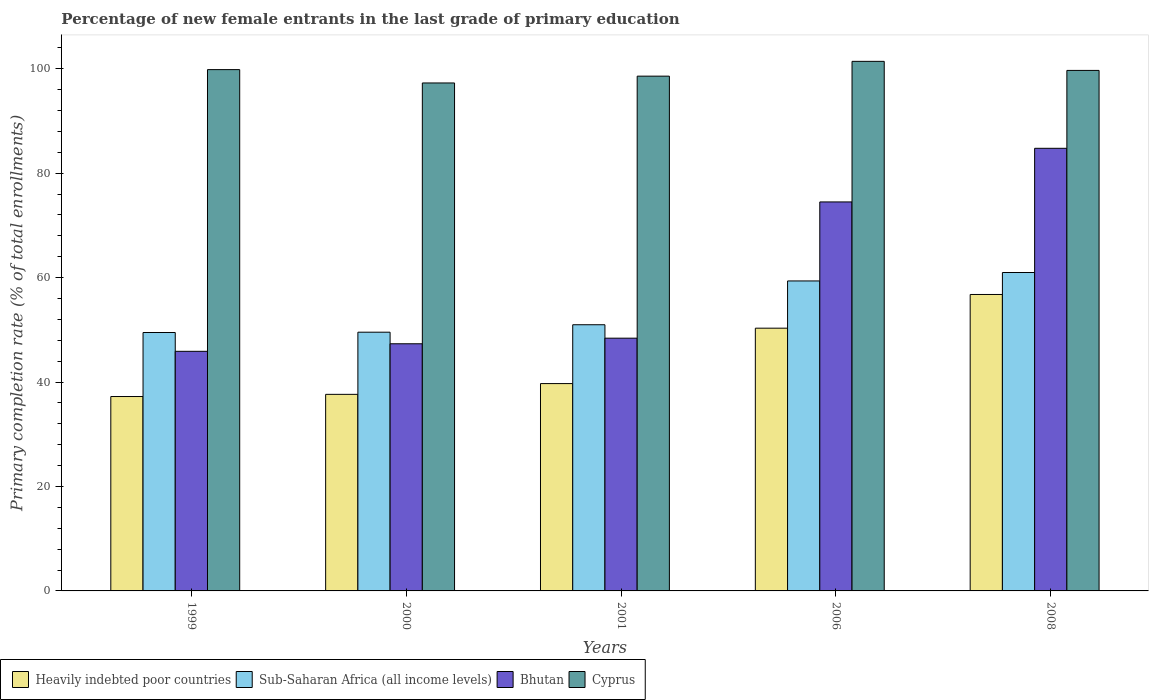Are the number of bars on each tick of the X-axis equal?
Your answer should be very brief. Yes. How many bars are there on the 1st tick from the left?
Keep it short and to the point. 4. How many bars are there on the 4th tick from the right?
Provide a succinct answer. 4. What is the label of the 1st group of bars from the left?
Offer a very short reply. 1999. What is the percentage of new female entrants in Bhutan in 2006?
Make the answer very short. 74.49. Across all years, what is the maximum percentage of new female entrants in Cyprus?
Keep it short and to the point. 101.41. Across all years, what is the minimum percentage of new female entrants in Cyprus?
Ensure brevity in your answer.  97.27. What is the total percentage of new female entrants in Cyprus in the graph?
Your response must be concise. 496.77. What is the difference between the percentage of new female entrants in Cyprus in 1999 and that in 2001?
Your response must be concise. 1.25. What is the difference between the percentage of new female entrants in Sub-Saharan Africa (all income levels) in 2008 and the percentage of new female entrants in Bhutan in 2000?
Keep it short and to the point. 13.65. What is the average percentage of new female entrants in Bhutan per year?
Your response must be concise. 60.17. In the year 2001, what is the difference between the percentage of new female entrants in Bhutan and percentage of new female entrants in Sub-Saharan Africa (all income levels)?
Give a very brief answer. -2.57. In how many years, is the percentage of new female entrants in Bhutan greater than 12 %?
Give a very brief answer. 5. What is the ratio of the percentage of new female entrants in Heavily indebted poor countries in 1999 to that in 2000?
Give a very brief answer. 0.99. What is the difference between the highest and the second highest percentage of new female entrants in Sub-Saharan Africa (all income levels)?
Keep it short and to the point. 1.62. What is the difference between the highest and the lowest percentage of new female entrants in Heavily indebted poor countries?
Offer a very short reply. 19.54. In how many years, is the percentage of new female entrants in Sub-Saharan Africa (all income levels) greater than the average percentage of new female entrants in Sub-Saharan Africa (all income levels) taken over all years?
Provide a short and direct response. 2. What does the 4th bar from the left in 2006 represents?
Your answer should be compact. Cyprus. What does the 4th bar from the right in 1999 represents?
Give a very brief answer. Heavily indebted poor countries. Is it the case that in every year, the sum of the percentage of new female entrants in Sub-Saharan Africa (all income levels) and percentage of new female entrants in Bhutan is greater than the percentage of new female entrants in Heavily indebted poor countries?
Provide a succinct answer. Yes. How many bars are there?
Your answer should be very brief. 20. How many years are there in the graph?
Your answer should be compact. 5. Are the values on the major ticks of Y-axis written in scientific E-notation?
Offer a very short reply. No. Does the graph contain any zero values?
Make the answer very short. No. Does the graph contain grids?
Your answer should be compact. No. Where does the legend appear in the graph?
Ensure brevity in your answer.  Bottom left. How many legend labels are there?
Make the answer very short. 4. How are the legend labels stacked?
Give a very brief answer. Horizontal. What is the title of the graph?
Your answer should be very brief. Percentage of new female entrants in the last grade of primary education. What is the label or title of the X-axis?
Make the answer very short. Years. What is the label or title of the Y-axis?
Your answer should be compact. Primary completion rate (% of total enrollments). What is the Primary completion rate (% of total enrollments) in Heavily indebted poor countries in 1999?
Offer a very short reply. 37.23. What is the Primary completion rate (% of total enrollments) in Sub-Saharan Africa (all income levels) in 1999?
Ensure brevity in your answer.  49.48. What is the Primary completion rate (% of total enrollments) of Bhutan in 1999?
Your answer should be very brief. 45.88. What is the Primary completion rate (% of total enrollments) of Cyprus in 1999?
Keep it short and to the point. 99.83. What is the Primary completion rate (% of total enrollments) of Heavily indebted poor countries in 2000?
Your response must be concise. 37.64. What is the Primary completion rate (% of total enrollments) of Sub-Saharan Africa (all income levels) in 2000?
Your answer should be compact. 49.55. What is the Primary completion rate (% of total enrollments) of Bhutan in 2000?
Your answer should be very brief. 47.33. What is the Primary completion rate (% of total enrollments) in Cyprus in 2000?
Offer a terse response. 97.27. What is the Primary completion rate (% of total enrollments) of Heavily indebted poor countries in 2001?
Provide a succinct answer. 39.71. What is the Primary completion rate (% of total enrollments) of Sub-Saharan Africa (all income levels) in 2001?
Your response must be concise. 50.97. What is the Primary completion rate (% of total enrollments) of Bhutan in 2001?
Provide a succinct answer. 48.4. What is the Primary completion rate (% of total enrollments) in Cyprus in 2001?
Make the answer very short. 98.58. What is the Primary completion rate (% of total enrollments) in Heavily indebted poor countries in 2006?
Your response must be concise. 50.31. What is the Primary completion rate (% of total enrollments) in Sub-Saharan Africa (all income levels) in 2006?
Offer a very short reply. 59.36. What is the Primary completion rate (% of total enrollments) in Bhutan in 2006?
Give a very brief answer. 74.49. What is the Primary completion rate (% of total enrollments) in Cyprus in 2006?
Make the answer very short. 101.41. What is the Primary completion rate (% of total enrollments) in Heavily indebted poor countries in 2008?
Your answer should be very brief. 56.77. What is the Primary completion rate (% of total enrollments) in Sub-Saharan Africa (all income levels) in 2008?
Give a very brief answer. 60.98. What is the Primary completion rate (% of total enrollments) of Bhutan in 2008?
Provide a succinct answer. 84.76. What is the Primary completion rate (% of total enrollments) in Cyprus in 2008?
Provide a succinct answer. 99.68. Across all years, what is the maximum Primary completion rate (% of total enrollments) of Heavily indebted poor countries?
Your answer should be compact. 56.77. Across all years, what is the maximum Primary completion rate (% of total enrollments) of Sub-Saharan Africa (all income levels)?
Offer a terse response. 60.98. Across all years, what is the maximum Primary completion rate (% of total enrollments) of Bhutan?
Make the answer very short. 84.76. Across all years, what is the maximum Primary completion rate (% of total enrollments) in Cyprus?
Keep it short and to the point. 101.41. Across all years, what is the minimum Primary completion rate (% of total enrollments) in Heavily indebted poor countries?
Offer a very short reply. 37.23. Across all years, what is the minimum Primary completion rate (% of total enrollments) in Sub-Saharan Africa (all income levels)?
Your answer should be compact. 49.48. Across all years, what is the minimum Primary completion rate (% of total enrollments) in Bhutan?
Your answer should be very brief. 45.88. Across all years, what is the minimum Primary completion rate (% of total enrollments) in Cyprus?
Offer a very short reply. 97.27. What is the total Primary completion rate (% of total enrollments) of Heavily indebted poor countries in the graph?
Offer a terse response. 221.66. What is the total Primary completion rate (% of total enrollments) in Sub-Saharan Africa (all income levels) in the graph?
Make the answer very short. 270.34. What is the total Primary completion rate (% of total enrollments) of Bhutan in the graph?
Offer a terse response. 300.86. What is the total Primary completion rate (% of total enrollments) of Cyprus in the graph?
Provide a succinct answer. 496.77. What is the difference between the Primary completion rate (% of total enrollments) of Heavily indebted poor countries in 1999 and that in 2000?
Your response must be concise. -0.41. What is the difference between the Primary completion rate (% of total enrollments) in Sub-Saharan Africa (all income levels) in 1999 and that in 2000?
Ensure brevity in your answer.  -0.06. What is the difference between the Primary completion rate (% of total enrollments) in Bhutan in 1999 and that in 2000?
Make the answer very short. -1.45. What is the difference between the Primary completion rate (% of total enrollments) of Cyprus in 1999 and that in 2000?
Ensure brevity in your answer.  2.55. What is the difference between the Primary completion rate (% of total enrollments) of Heavily indebted poor countries in 1999 and that in 2001?
Your answer should be very brief. -2.48. What is the difference between the Primary completion rate (% of total enrollments) in Sub-Saharan Africa (all income levels) in 1999 and that in 2001?
Give a very brief answer. -1.49. What is the difference between the Primary completion rate (% of total enrollments) of Bhutan in 1999 and that in 2001?
Give a very brief answer. -2.52. What is the difference between the Primary completion rate (% of total enrollments) in Cyprus in 1999 and that in 2001?
Your answer should be very brief. 1.25. What is the difference between the Primary completion rate (% of total enrollments) of Heavily indebted poor countries in 1999 and that in 2006?
Provide a succinct answer. -13.09. What is the difference between the Primary completion rate (% of total enrollments) in Sub-Saharan Africa (all income levels) in 1999 and that in 2006?
Offer a very short reply. -9.88. What is the difference between the Primary completion rate (% of total enrollments) in Bhutan in 1999 and that in 2006?
Your answer should be very brief. -28.61. What is the difference between the Primary completion rate (% of total enrollments) in Cyprus in 1999 and that in 2006?
Give a very brief answer. -1.58. What is the difference between the Primary completion rate (% of total enrollments) of Heavily indebted poor countries in 1999 and that in 2008?
Your answer should be compact. -19.54. What is the difference between the Primary completion rate (% of total enrollments) of Sub-Saharan Africa (all income levels) in 1999 and that in 2008?
Give a very brief answer. -11.49. What is the difference between the Primary completion rate (% of total enrollments) in Bhutan in 1999 and that in 2008?
Offer a very short reply. -38.88. What is the difference between the Primary completion rate (% of total enrollments) in Cyprus in 1999 and that in 2008?
Your answer should be compact. 0.15. What is the difference between the Primary completion rate (% of total enrollments) in Heavily indebted poor countries in 2000 and that in 2001?
Make the answer very short. -2.06. What is the difference between the Primary completion rate (% of total enrollments) of Sub-Saharan Africa (all income levels) in 2000 and that in 2001?
Your answer should be compact. -1.43. What is the difference between the Primary completion rate (% of total enrollments) in Bhutan in 2000 and that in 2001?
Ensure brevity in your answer.  -1.07. What is the difference between the Primary completion rate (% of total enrollments) of Cyprus in 2000 and that in 2001?
Offer a terse response. -1.31. What is the difference between the Primary completion rate (% of total enrollments) in Heavily indebted poor countries in 2000 and that in 2006?
Your answer should be compact. -12.67. What is the difference between the Primary completion rate (% of total enrollments) in Sub-Saharan Africa (all income levels) in 2000 and that in 2006?
Your response must be concise. -9.81. What is the difference between the Primary completion rate (% of total enrollments) of Bhutan in 2000 and that in 2006?
Your answer should be compact. -27.16. What is the difference between the Primary completion rate (% of total enrollments) of Cyprus in 2000 and that in 2006?
Provide a succinct answer. -4.14. What is the difference between the Primary completion rate (% of total enrollments) in Heavily indebted poor countries in 2000 and that in 2008?
Your answer should be very brief. -19.13. What is the difference between the Primary completion rate (% of total enrollments) in Sub-Saharan Africa (all income levels) in 2000 and that in 2008?
Keep it short and to the point. -11.43. What is the difference between the Primary completion rate (% of total enrollments) of Bhutan in 2000 and that in 2008?
Your answer should be compact. -37.43. What is the difference between the Primary completion rate (% of total enrollments) in Cyprus in 2000 and that in 2008?
Give a very brief answer. -2.4. What is the difference between the Primary completion rate (% of total enrollments) of Heavily indebted poor countries in 2001 and that in 2006?
Offer a very short reply. -10.61. What is the difference between the Primary completion rate (% of total enrollments) of Sub-Saharan Africa (all income levels) in 2001 and that in 2006?
Offer a terse response. -8.39. What is the difference between the Primary completion rate (% of total enrollments) in Bhutan in 2001 and that in 2006?
Keep it short and to the point. -26.09. What is the difference between the Primary completion rate (% of total enrollments) of Cyprus in 2001 and that in 2006?
Offer a very short reply. -2.83. What is the difference between the Primary completion rate (% of total enrollments) of Heavily indebted poor countries in 2001 and that in 2008?
Give a very brief answer. -17.06. What is the difference between the Primary completion rate (% of total enrollments) of Sub-Saharan Africa (all income levels) in 2001 and that in 2008?
Your answer should be very brief. -10.01. What is the difference between the Primary completion rate (% of total enrollments) in Bhutan in 2001 and that in 2008?
Your answer should be very brief. -36.36. What is the difference between the Primary completion rate (% of total enrollments) in Cyprus in 2001 and that in 2008?
Offer a terse response. -1.1. What is the difference between the Primary completion rate (% of total enrollments) of Heavily indebted poor countries in 2006 and that in 2008?
Give a very brief answer. -6.46. What is the difference between the Primary completion rate (% of total enrollments) of Sub-Saharan Africa (all income levels) in 2006 and that in 2008?
Keep it short and to the point. -1.62. What is the difference between the Primary completion rate (% of total enrollments) of Bhutan in 2006 and that in 2008?
Your answer should be compact. -10.27. What is the difference between the Primary completion rate (% of total enrollments) in Cyprus in 2006 and that in 2008?
Keep it short and to the point. 1.74. What is the difference between the Primary completion rate (% of total enrollments) of Heavily indebted poor countries in 1999 and the Primary completion rate (% of total enrollments) of Sub-Saharan Africa (all income levels) in 2000?
Make the answer very short. -12.32. What is the difference between the Primary completion rate (% of total enrollments) of Heavily indebted poor countries in 1999 and the Primary completion rate (% of total enrollments) of Bhutan in 2000?
Keep it short and to the point. -10.1. What is the difference between the Primary completion rate (% of total enrollments) of Heavily indebted poor countries in 1999 and the Primary completion rate (% of total enrollments) of Cyprus in 2000?
Keep it short and to the point. -60.05. What is the difference between the Primary completion rate (% of total enrollments) in Sub-Saharan Africa (all income levels) in 1999 and the Primary completion rate (% of total enrollments) in Bhutan in 2000?
Give a very brief answer. 2.15. What is the difference between the Primary completion rate (% of total enrollments) in Sub-Saharan Africa (all income levels) in 1999 and the Primary completion rate (% of total enrollments) in Cyprus in 2000?
Offer a very short reply. -47.79. What is the difference between the Primary completion rate (% of total enrollments) of Bhutan in 1999 and the Primary completion rate (% of total enrollments) of Cyprus in 2000?
Make the answer very short. -51.39. What is the difference between the Primary completion rate (% of total enrollments) in Heavily indebted poor countries in 1999 and the Primary completion rate (% of total enrollments) in Sub-Saharan Africa (all income levels) in 2001?
Offer a terse response. -13.74. What is the difference between the Primary completion rate (% of total enrollments) of Heavily indebted poor countries in 1999 and the Primary completion rate (% of total enrollments) of Bhutan in 2001?
Provide a succinct answer. -11.17. What is the difference between the Primary completion rate (% of total enrollments) of Heavily indebted poor countries in 1999 and the Primary completion rate (% of total enrollments) of Cyprus in 2001?
Your answer should be compact. -61.35. What is the difference between the Primary completion rate (% of total enrollments) of Sub-Saharan Africa (all income levels) in 1999 and the Primary completion rate (% of total enrollments) of Bhutan in 2001?
Offer a very short reply. 1.08. What is the difference between the Primary completion rate (% of total enrollments) of Sub-Saharan Africa (all income levels) in 1999 and the Primary completion rate (% of total enrollments) of Cyprus in 2001?
Provide a succinct answer. -49.09. What is the difference between the Primary completion rate (% of total enrollments) in Bhutan in 1999 and the Primary completion rate (% of total enrollments) in Cyprus in 2001?
Ensure brevity in your answer.  -52.7. What is the difference between the Primary completion rate (% of total enrollments) in Heavily indebted poor countries in 1999 and the Primary completion rate (% of total enrollments) in Sub-Saharan Africa (all income levels) in 2006?
Offer a terse response. -22.13. What is the difference between the Primary completion rate (% of total enrollments) of Heavily indebted poor countries in 1999 and the Primary completion rate (% of total enrollments) of Bhutan in 2006?
Provide a short and direct response. -37.26. What is the difference between the Primary completion rate (% of total enrollments) of Heavily indebted poor countries in 1999 and the Primary completion rate (% of total enrollments) of Cyprus in 2006?
Make the answer very short. -64.18. What is the difference between the Primary completion rate (% of total enrollments) of Sub-Saharan Africa (all income levels) in 1999 and the Primary completion rate (% of total enrollments) of Bhutan in 2006?
Keep it short and to the point. -25.01. What is the difference between the Primary completion rate (% of total enrollments) in Sub-Saharan Africa (all income levels) in 1999 and the Primary completion rate (% of total enrollments) in Cyprus in 2006?
Offer a terse response. -51.93. What is the difference between the Primary completion rate (% of total enrollments) in Bhutan in 1999 and the Primary completion rate (% of total enrollments) in Cyprus in 2006?
Give a very brief answer. -55.53. What is the difference between the Primary completion rate (% of total enrollments) of Heavily indebted poor countries in 1999 and the Primary completion rate (% of total enrollments) of Sub-Saharan Africa (all income levels) in 2008?
Your response must be concise. -23.75. What is the difference between the Primary completion rate (% of total enrollments) in Heavily indebted poor countries in 1999 and the Primary completion rate (% of total enrollments) in Bhutan in 2008?
Keep it short and to the point. -47.53. What is the difference between the Primary completion rate (% of total enrollments) in Heavily indebted poor countries in 1999 and the Primary completion rate (% of total enrollments) in Cyprus in 2008?
Offer a very short reply. -62.45. What is the difference between the Primary completion rate (% of total enrollments) of Sub-Saharan Africa (all income levels) in 1999 and the Primary completion rate (% of total enrollments) of Bhutan in 2008?
Provide a succinct answer. -35.28. What is the difference between the Primary completion rate (% of total enrollments) of Sub-Saharan Africa (all income levels) in 1999 and the Primary completion rate (% of total enrollments) of Cyprus in 2008?
Keep it short and to the point. -50.19. What is the difference between the Primary completion rate (% of total enrollments) in Bhutan in 1999 and the Primary completion rate (% of total enrollments) in Cyprus in 2008?
Your answer should be compact. -53.79. What is the difference between the Primary completion rate (% of total enrollments) in Heavily indebted poor countries in 2000 and the Primary completion rate (% of total enrollments) in Sub-Saharan Africa (all income levels) in 2001?
Your answer should be very brief. -13.33. What is the difference between the Primary completion rate (% of total enrollments) in Heavily indebted poor countries in 2000 and the Primary completion rate (% of total enrollments) in Bhutan in 2001?
Your answer should be very brief. -10.76. What is the difference between the Primary completion rate (% of total enrollments) in Heavily indebted poor countries in 2000 and the Primary completion rate (% of total enrollments) in Cyprus in 2001?
Your answer should be very brief. -60.94. What is the difference between the Primary completion rate (% of total enrollments) in Sub-Saharan Africa (all income levels) in 2000 and the Primary completion rate (% of total enrollments) in Bhutan in 2001?
Your response must be concise. 1.15. What is the difference between the Primary completion rate (% of total enrollments) in Sub-Saharan Africa (all income levels) in 2000 and the Primary completion rate (% of total enrollments) in Cyprus in 2001?
Provide a short and direct response. -49.03. What is the difference between the Primary completion rate (% of total enrollments) of Bhutan in 2000 and the Primary completion rate (% of total enrollments) of Cyprus in 2001?
Give a very brief answer. -51.25. What is the difference between the Primary completion rate (% of total enrollments) in Heavily indebted poor countries in 2000 and the Primary completion rate (% of total enrollments) in Sub-Saharan Africa (all income levels) in 2006?
Ensure brevity in your answer.  -21.72. What is the difference between the Primary completion rate (% of total enrollments) of Heavily indebted poor countries in 2000 and the Primary completion rate (% of total enrollments) of Bhutan in 2006?
Your response must be concise. -36.85. What is the difference between the Primary completion rate (% of total enrollments) of Heavily indebted poor countries in 2000 and the Primary completion rate (% of total enrollments) of Cyprus in 2006?
Offer a very short reply. -63.77. What is the difference between the Primary completion rate (% of total enrollments) of Sub-Saharan Africa (all income levels) in 2000 and the Primary completion rate (% of total enrollments) of Bhutan in 2006?
Give a very brief answer. -24.94. What is the difference between the Primary completion rate (% of total enrollments) in Sub-Saharan Africa (all income levels) in 2000 and the Primary completion rate (% of total enrollments) in Cyprus in 2006?
Offer a very short reply. -51.87. What is the difference between the Primary completion rate (% of total enrollments) in Bhutan in 2000 and the Primary completion rate (% of total enrollments) in Cyprus in 2006?
Offer a terse response. -54.08. What is the difference between the Primary completion rate (% of total enrollments) in Heavily indebted poor countries in 2000 and the Primary completion rate (% of total enrollments) in Sub-Saharan Africa (all income levels) in 2008?
Offer a very short reply. -23.33. What is the difference between the Primary completion rate (% of total enrollments) in Heavily indebted poor countries in 2000 and the Primary completion rate (% of total enrollments) in Bhutan in 2008?
Your response must be concise. -47.12. What is the difference between the Primary completion rate (% of total enrollments) of Heavily indebted poor countries in 2000 and the Primary completion rate (% of total enrollments) of Cyprus in 2008?
Make the answer very short. -62.03. What is the difference between the Primary completion rate (% of total enrollments) of Sub-Saharan Africa (all income levels) in 2000 and the Primary completion rate (% of total enrollments) of Bhutan in 2008?
Make the answer very short. -35.21. What is the difference between the Primary completion rate (% of total enrollments) in Sub-Saharan Africa (all income levels) in 2000 and the Primary completion rate (% of total enrollments) in Cyprus in 2008?
Offer a terse response. -50.13. What is the difference between the Primary completion rate (% of total enrollments) in Bhutan in 2000 and the Primary completion rate (% of total enrollments) in Cyprus in 2008?
Your answer should be compact. -52.35. What is the difference between the Primary completion rate (% of total enrollments) of Heavily indebted poor countries in 2001 and the Primary completion rate (% of total enrollments) of Sub-Saharan Africa (all income levels) in 2006?
Give a very brief answer. -19.66. What is the difference between the Primary completion rate (% of total enrollments) in Heavily indebted poor countries in 2001 and the Primary completion rate (% of total enrollments) in Bhutan in 2006?
Ensure brevity in your answer.  -34.79. What is the difference between the Primary completion rate (% of total enrollments) of Heavily indebted poor countries in 2001 and the Primary completion rate (% of total enrollments) of Cyprus in 2006?
Provide a succinct answer. -61.71. What is the difference between the Primary completion rate (% of total enrollments) of Sub-Saharan Africa (all income levels) in 2001 and the Primary completion rate (% of total enrollments) of Bhutan in 2006?
Provide a succinct answer. -23.52. What is the difference between the Primary completion rate (% of total enrollments) of Sub-Saharan Africa (all income levels) in 2001 and the Primary completion rate (% of total enrollments) of Cyprus in 2006?
Ensure brevity in your answer.  -50.44. What is the difference between the Primary completion rate (% of total enrollments) of Bhutan in 2001 and the Primary completion rate (% of total enrollments) of Cyprus in 2006?
Keep it short and to the point. -53.01. What is the difference between the Primary completion rate (% of total enrollments) of Heavily indebted poor countries in 2001 and the Primary completion rate (% of total enrollments) of Sub-Saharan Africa (all income levels) in 2008?
Ensure brevity in your answer.  -21.27. What is the difference between the Primary completion rate (% of total enrollments) in Heavily indebted poor countries in 2001 and the Primary completion rate (% of total enrollments) in Bhutan in 2008?
Provide a short and direct response. -45.05. What is the difference between the Primary completion rate (% of total enrollments) in Heavily indebted poor countries in 2001 and the Primary completion rate (% of total enrollments) in Cyprus in 2008?
Offer a terse response. -59.97. What is the difference between the Primary completion rate (% of total enrollments) in Sub-Saharan Africa (all income levels) in 2001 and the Primary completion rate (% of total enrollments) in Bhutan in 2008?
Offer a terse response. -33.79. What is the difference between the Primary completion rate (% of total enrollments) in Sub-Saharan Africa (all income levels) in 2001 and the Primary completion rate (% of total enrollments) in Cyprus in 2008?
Offer a terse response. -48.7. What is the difference between the Primary completion rate (% of total enrollments) of Bhutan in 2001 and the Primary completion rate (% of total enrollments) of Cyprus in 2008?
Keep it short and to the point. -51.28. What is the difference between the Primary completion rate (% of total enrollments) in Heavily indebted poor countries in 2006 and the Primary completion rate (% of total enrollments) in Sub-Saharan Africa (all income levels) in 2008?
Ensure brevity in your answer.  -10.66. What is the difference between the Primary completion rate (% of total enrollments) of Heavily indebted poor countries in 2006 and the Primary completion rate (% of total enrollments) of Bhutan in 2008?
Make the answer very short. -34.45. What is the difference between the Primary completion rate (% of total enrollments) of Heavily indebted poor countries in 2006 and the Primary completion rate (% of total enrollments) of Cyprus in 2008?
Offer a very short reply. -49.36. What is the difference between the Primary completion rate (% of total enrollments) of Sub-Saharan Africa (all income levels) in 2006 and the Primary completion rate (% of total enrollments) of Bhutan in 2008?
Your response must be concise. -25.4. What is the difference between the Primary completion rate (% of total enrollments) in Sub-Saharan Africa (all income levels) in 2006 and the Primary completion rate (% of total enrollments) in Cyprus in 2008?
Give a very brief answer. -40.32. What is the difference between the Primary completion rate (% of total enrollments) in Bhutan in 2006 and the Primary completion rate (% of total enrollments) in Cyprus in 2008?
Your response must be concise. -25.19. What is the average Primary completion rate (% of total enrollments) of Heavily indebted poor countries per year?
Offer a terse response. 44.33. What is the average Primary completion rate (% of total enrollments) in Sub-Saharan Africa (all income levels) per year?
Give a very brief answer. 54.07. What is the average Primary completion rate (% of total enrollments) of Bhutan per year?
Offer a very short reply. 60.17. What is the average Primary completion rate (% of total enrollments) in Cyprus per year?
Your answer should be very brief. 99.35. In the year 1999, what is the difference between the Primary completion rate (% of total enrollments) of Heavily indebted poor countries and Primary completion rate (% of total enrollments) of Sub-Saharan Africa (all income levels)?
Your response must be concise. -12.26. In the year 1999, what is the difference between the Primary completion rate (% of total enrollments) in Heavily indebted poor countries and Primary completion rate (% of total enrollments) in Bhutan?
Your response must be concise. -8.65. In the year 1999, what is the difference between the Primary completion rate (% of total enrollments) of Heavily indebted poor countries and Primary completion rate (% of total enrollments) of Cyprus?
Provide a succinct answer. -62.6. In the year 1999, what is the difference between the Primary completion rate (% of total enrollments) of Sub-Saharan Africa (all income levels) and Primary completion rate (% of total enrollments) of Bhutan?
Make the answer very short. 3.6. In the year 1999, what is the difference between the Primary completion rate (% of total enrollments) in Sub-Saharan Africa (all income levels) and Primary completion rate (% of total enrollments) in Cyprus?
Keep it short and to the point. -50.34. In the year 1999, what is the difference between the Primary completion rate (% of total enrollments) of Bhutan and Primary completion rate (% of total enrollments) of Cyprus?
Give a very brief answer. -53.95. In the year 2000, what is the difference between the Primary completion rate (% of total enrollments) of Heavily indebted poor countries and Primary completion rate (% of total enrollments) of Sub-Saharan Africa (all income levels)?
Keep it short and to the point. -11.9. In the year 2000, what is the difference between the Primary completion rate (% of total enrollments) of Heavily indebted poor countries and Primary completion rate (% of total enrollments) of Bhutan?
Give a very brief answer. -9.69. In the year 2000, what is the difference between the Primary completion rate (% of total enrollments) of Heavily indebted poor countries and Primary completion rate (% of total enrollments) of Cyprus?
Provide a succinct answer. -59.63. In the year 2000, what is the difference between the Primary completion rate (% of total enrollments) of Sub-Saharan Africa (all income levels) and Primary completion rate (% of total enrollments) of Bhutan?
Make the answer very short. 2.22. In the year 2000, what is the difference between the Primary completion rate (% of total enrollments) of Sub-Saharan Africa (all income levels) and Primary completion rate (% of total enrollments) of Cyprus?
Provide a succinct answer. -47.73. In the year 2000, what is the difference between the Primary completion rate (% of total enrollments) of Bhutan and Primary completion rate (% of total enrollments) of Cyprus?
Offer a very short reply. -49.94. In the year 2001, what is the difference between the Primary completion rate (% of total enrollments) in Heavily indebted poor countries and Primary completion rate (% of total enrollments) in Sub-Saharan Africa (all income levels)?
Offer a very short reply. -11.27. In the year 2001, what is the difference between the Primary completion rate (% of total enrollments) in Heavily indebted poor countries and Primary completion rate (% of total enrollments) in Bhutan?
Give a very brief answer. -8.69. In the year 2001, what is the difference between the Primary completion rate (% of total enrollments) in Heavily indebted poor countries and Primary completion rate (% of total enrollments) in Cyprus?
Provide a short and direct response. -58.87. In the year 2001, what is the difference between the Primary completion rate (% of total enrollments) of Sub-Saharan Africa (all income levels) and Primary completion rate (% of total enrollments) of Bhutan?
Make the answer very short. 2.57. In the year 2001, what is the difference between the Primary completion rate (% of total enrollments) of Sub-Saharan Africa (all income levels) and Primary completion rate (% of total enrollments) of Cyprus?
Keep it short and to the point. -47.61. In the year 2001, what is the difference between the Primary completion rate (% of total enrollments) of Bhutan and Primary completion rate (% of total enrollments) of Cyprus?
Your answer should be very brief. -50.18. In the year 2006, what is the difference between the Primary completion rate (% of total enrollments) of Heavily indebted poor countries and Primary completion rate (% of total enrollments) of Sub-Saharan Africa (all income levels)?
Your answer should be very brief. -9.05. In the year 2006, what is the difference between the Primary completion rate (% of total enrollments) of Heavily indebted poor countries and Primary completion rate (% of total enrollments) of Bhutan?
Give a very brief answer. -24.18. In the year 2006, what is the difference between the Primary completion rate (% of total enrollments) in Heavily indebted poor countries and Primary completion rate (% of total enrollments) in Cyprus?
Give a very brief answer. -51.1. In the year 2006, what is the difference between the Primary completion rate (% of total enrollments) in Sub-Saharan Africa (all income levels) and Primary completion rate (% of total enrollments) in Bhutan?
Provide a short and direct response. -15.13. In the year 2006, what is the difference between the Primary completion rate (% of total enrollments) in Sub-Saharan Africa (all income levels) and Primary completion rate (% of total enrollments) in Cyprus?
Keep it short and to the point. -42.05. In the year 2006, what is the difference between the Primary completion rate (% of total enrollments) in Bhutan and Primary completion rate (% of total enrollments) in Cyprus?
Provide a succinct answer. -26.92. In the year 2008, what is the difference between the Primary completion rate (% of total enrollments) of Heavily indebted poor countries and Primary completion rate (% of total enrollments) of Sub-Saharan Africa (all income levels)?
Give a very brief answer. -4.21. In the year 2008, what is the difference between the Primary completion rate (% of total enrollments) in Heavily indebted poor countries and Primary completion rate (% of total enrollments) in Bhutan?
Give a very brief answer. -27.99. In the year 2008, what is the difference between the Primary completion rate (% of total enrollments) in Heavily indebted poor countries and Primary completion rate (% of total enrollments) in Cyprus?
Provide a succinct answer. -42.91. In the year 2008, what is the difference between the Primary completion rate (% of total enrollments) of Sub-Saharan Africa (all income levels) and Primary completion rate (% of total enrollments) of Bhutan?
Offer a terse response. -23.78. In the year 2008, what is the difference between the Primary completion rate (% of total enrollments) in Sub-Saharan Africa (all income levels) and Primary completion rate (% of total enrollments) in Cyprus?
Offer a very short reply. -38.7. In the year 2008, what is the difference between the Primary completion rate (% of total enrollments) in Bhutan and Primary completion rate (% of total enrollments) in Cyprus?
Offer a very short reply. -14.92. What is the ratio of the Primary completion rate (% of total enrollments) in Bhutan in 1999 to that in 2000?
Make the answer very short. 0.97. What is the ratio of the Primary completion rate (% of total enrollments) of Cyprus in 1999 to that in 2000?
Keep it short and to the point. 1.03. What is the ratio of the Primary completion rate (% of total enrollments) in Heavily indebted poor countries in 1999 to that in 2001?
Give a very brief answer. 0.94. What is the ratio of the Primary completion rate (% of total enrollments) in Sub-Saharan Africa (all income levels) in 1999 to that in 2001?
Give a very brief answer. 0.97. What is the ratio of the Primary completion rate (% of total enrollments) of Bhutan in 1999 to that in 2001?
Your response must be concise. 0.95. What is the ratio of the Primary completion rate (% of total enrollments) of Cyprus in 1999 to that in 2001?
Your response must be concise. 1.01. What is the ratio of the Primary completion rate (% of total enrollments) in Heavily indebted poor countries in 1999 to that in 2006?
Offer a very short reply. 0.74. What is the ratio of the Primary completion rate (% of total enrollments) in Sub-Saharan Africa (all income levels) in 1999 to that in 2006?
Provide a short and direct response. 0.83. What is the ratio of the Primary completion rate (% of total enrollments) in Bhutan in 1999 to that in 2006?
Provide a succinct answer. 0.62. What is the ratio of the Primary completion rate (% of total enrollments) of Cyprus in 1999 to that in 2006?
Your answer should be compact. 0.98. What is the ratio of the Primary completion rate (% of total enrollments) of Heavily indebted poor countries in 1999 to that in 2008?
Your answer should be compact. 0.66. What is the ratio of the Primary completion rate (% of total enrollments) in Sub-Saharan Africa (all income levels) in 1999 to that in 2008?
Provide a succinct answer. 0.81. What is the ratio of the Primary completion rate (% of total enrollments) of Bhutan in 1999 to that in 2008?
Give a very brief answer. 0.54. What is the ratio of the Primary completion rate (% of total enrollments) in Heavily indebted poor countries in 2000 to that in 2001?
Your answer should be compact. 0.95. What is the ratio of the Primary completion rate (% of total enrollments) of Sub-Saharan Africa (all income levels) in 2000 to that in 2001?
Ensure brevity in your answer.  0.97. What is the ratio of the Primary completion rate (% of total enrollments) of Bhutan in 2000 to that in 2001?
Make the answer very short. 0.98. What is the ratio of the Primary completion rate (% of total enrollments) in Cyprus in 2000 to that in 2001?
Ensure brevity in your answer.  0.99. What is the ratio of the Primary completion rate (% of total enrollments) of Heavily indebted poor countries in 2000 to that in 2006?
Make the answer very short. 0.75. What is the ratio of the Primary completion rate (% of total enrollments) in Sub-Saharan Africa (all income levels) in 2000 to that in 2006?
Keep it short and to the point. 0.83. What is the ratio of the Primary completion rate (% of total enrollments) of Bhutan in 2000 to that in 2006?
Offer a very short reply. 0.64. What is the ratio of the Primary completion rate (% of total enrollments) in Cyprus in 2000 to that in 2006?
Offer a terse response. 0.96. What is the ratio of the Primary completion rate (% of total enrollments) of Heavily indebted poor countries in 2000 to that in 2008?
Offer a very short reply. 0.66. What is the ratio of the Primary completion rate (% of total enrollments) in Sub-Saharan Africa (all income levels) in 2000 to that in 2008?
Ensure brevity in your answer.  0.81. What is the ratio of the Primary completion rate (% of total enrollments) of Bhutan in 2000 to that in 2008?
Make the answer very short. 0.56. What is the ratio of the Primary completion rate (% of total enrollments) of Cyprus in 2000 to that in 2008?
Ensure brevity in your answer.  0.98. What is the ratio of the Primary completion rate (% of total enrollments) in Heavily indebted poor countries in 2001 to that in 2006?
Your answer should be very brief. 0.79. What is the ratio of the Primary completion rate (% of total enrollments) of Sub-Saharan Africa (all income levels) in 2001 to that in 2006?
Provide a succinct answer. 0.86. What is the ratio of the Primary completion rate (% of total enrollments) in Bhutan in 2001 to that in 2006?
Ensure brevity in your answer.  0.65. What is the ratio of the Primary completion rate (% of total enrollments) of Cyprus in 2001 to that in 2006?
Offer a very short reply. 0.97. What is the ratio of the Primary completion rate (% of total enrollments) of Heavily indebted poor countries in 2001 to that in 2008?
Provide a short and direct response. 0.7. What is the ratio of the Primary completion rate (% of total enrollments) of Sub-Saharan Africa (all income levels) in 2001 to that in 2008?
Provide a succinct answer. 0.84. What is the ratio of the Primary completion rate (% of total enrollments) in Bhutan in 2001 to that in 2008?
Make the answer very short. 0.57. What is the ratio of the Primary completion rate (% of total enrollments) of Heavily indebted poor countries in 2006 to that in 2008?
Make the answer very short. 0.89. What is the ratio of the Primary completion rate (% of total enrollments) of Sub-Saharan Africa (all income levels) in 2006 to that in 2008?
Your answer should be very brief. 0.97. What is the ratio of the Primary completion rate (% of total enrollments) in Bhutan in 2006 to that in 2008?
Keep it short and to the point. 0.88. What is the ratio of the Primary completion rate (% of total enrollments) in Cyprus in 2006 to that in 2008?
Give a very brief answer. 1.02. What is the difference between the highest and the second highest Primary completion rate (% of total enrollments) of Heavily indebted poor countries?
Offer a very short reply. 6.46. What is the difference between the highest and the second highest Primary completion rate (% of total enrollments) in Sub-Saharan Africa (all income levels)?
Offer a terse response. 1.62. What is the difference between the highest and the second highest Primary completion rate (% of total enrollments) in Bhutan?
Give a very brief answer. 10.27. What is the difference between the highest and the second highest Primary completion rate (% of total enrollments) of Cyprus?
Provide a succinct answer. 1.58. What is the difference between the highest and the lowest Primary completion rate (% of total enrollments) of Heavily indebted poor countries?
Provide a short and direct response. 19.54. What is the difference between the highest and the lowest Primary completion rate (% of total enrollments) of Sub-Saharan Africa (all income levels)?
Offer a terse response. 11.49. What is the difference between the highest and the lowest Primary completion rate (% of total enrollments) of Bhutan?
Your response must be concise. 38.88. What is the difference between the highest and the lowest Primary completion rate (% of total enrollments) of Cyprus?
Ensure brevity in your answer.  4.14. 